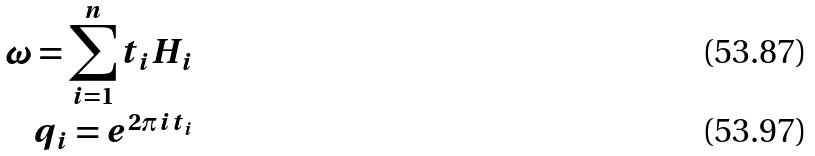<formula> <loc_0><loc_0><loc_500><loc_500>\omega = \sum _ { i = 1 } ^ { n } t _ { i } H _ { i } \\ q _ { i } = e ^ { 2 \pi i t _ { i } }</formula> 